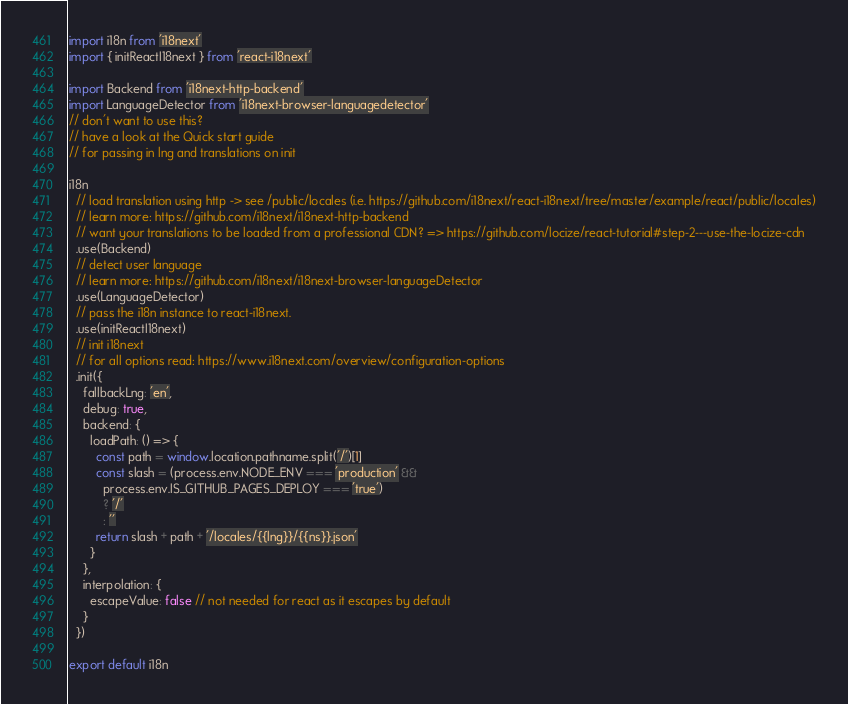Convert code to text. <code><loc_0><loc_0><loc_500><loc_500><_TypeScript_>import i18n from 'i18next'
import { initReactI18next } from 'react-i18next'

import Backend from 'i18next-http-backend'
import LanguageDetector from 'i18next-browser-languagedetector'
// don't want to use this?
// have a look at the Quick start guide
// for passing in lng and translations on init

i18n
  // load translation using http -> see /public/locales (i.e. https://github.com/i18next/react-i18next/tree/master/example/react/public/locales)
  // learn more: https://github.com/i18next/i18next-http-backend
  // want your translations to be loaded from a professional CDN? => https://github.com/locize/react-tutorial#step-2---use-the-locize-cdn
  .use(Backend)
  // detect user language
  // learn more: https://github.com/i18next/i18next-browser-languageDetector
  .use(LanguageDetector)
  // pass the i18n instance to react-i18next.
  .use(initReactI18next)
  // init i18next
  // for all options read: https://www.i18next.com/overview/configuration-options
  .init({
    fallbackLng: 'en',
    debug: true,
    backend: {
      loadPath: () => {
        const path = window.location.pathname.split('/')[1]
        const slash = (process.env.NODE_ENV === 'production' &&
          process.env.IS_GITHUB_PAGES_DEPLOY === 'true')
          ? '/'
          : ''
        return slash + path + '/locales/{{lng}}/{{ns}}.json'
      }
    },
    interpolation: {
      escapeValue: false // not needed for react as it escapes by default
    }
  })

export default i18n
</code> 